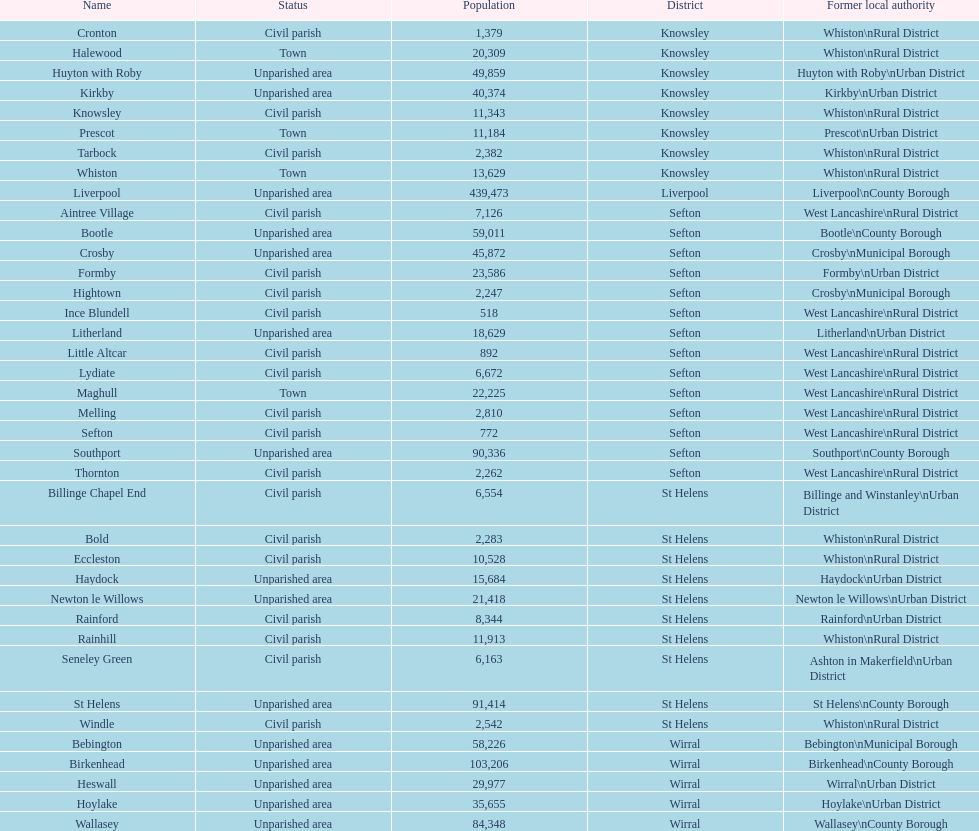How many people live in the bold civil parish? 2,283. 